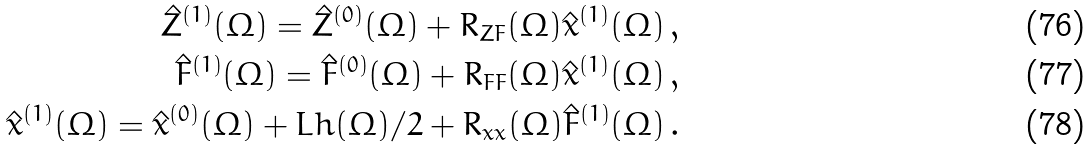<formula> <loc_0><loc_0><loc_500><loc_500>\hat { Z } ^ { ( 1 ) } ( \Omega ) = \hat { Z } ^ { ( 0 ) } ( \Omega ) + R _ { Z F } ( \Omega ) \hat { x } ^ { ( 1 ) } ( \Omega ) \, , \\ \hat { F } ^ { ( 1 ) } ( \Omega ) = \hat { F } ^ { ( 0 ) } ( \Omega ) + R _ { F F } ( \Omega ) \hat { x } ^ { ( 1 ) } ( \Omega ) \, , \\ \hat { x } ^ { ( 1 ) } ( \Omega ) = \hat { x } ^ { ( 0 ) } ( \Omega ) + L h ( \Omega ) / 2 + R _ { x x } ( \Omega ) \hat { F } ^ { ( 1 ) } ( \Omega ) \, .</formula> 